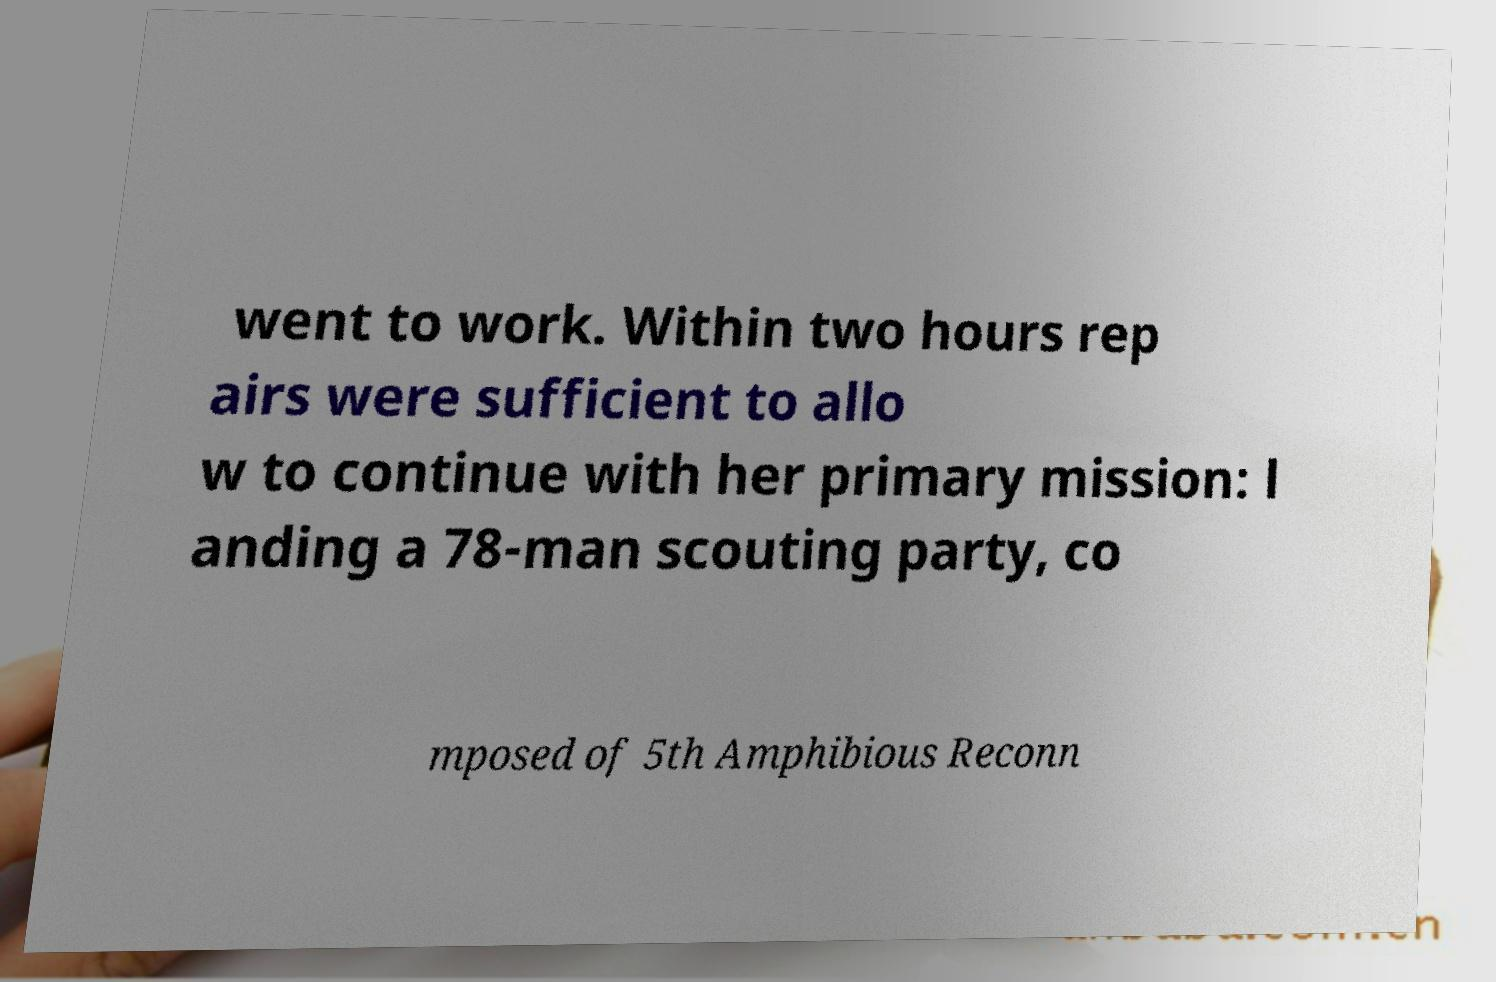Please read and relay the text visible in this image. What does it say? went to work. Within two hours rep airs were sufficient to allo w to continue with her primary mission: l anding a 78-man scouting party, co mposed of 5th Amphibious Reconn 